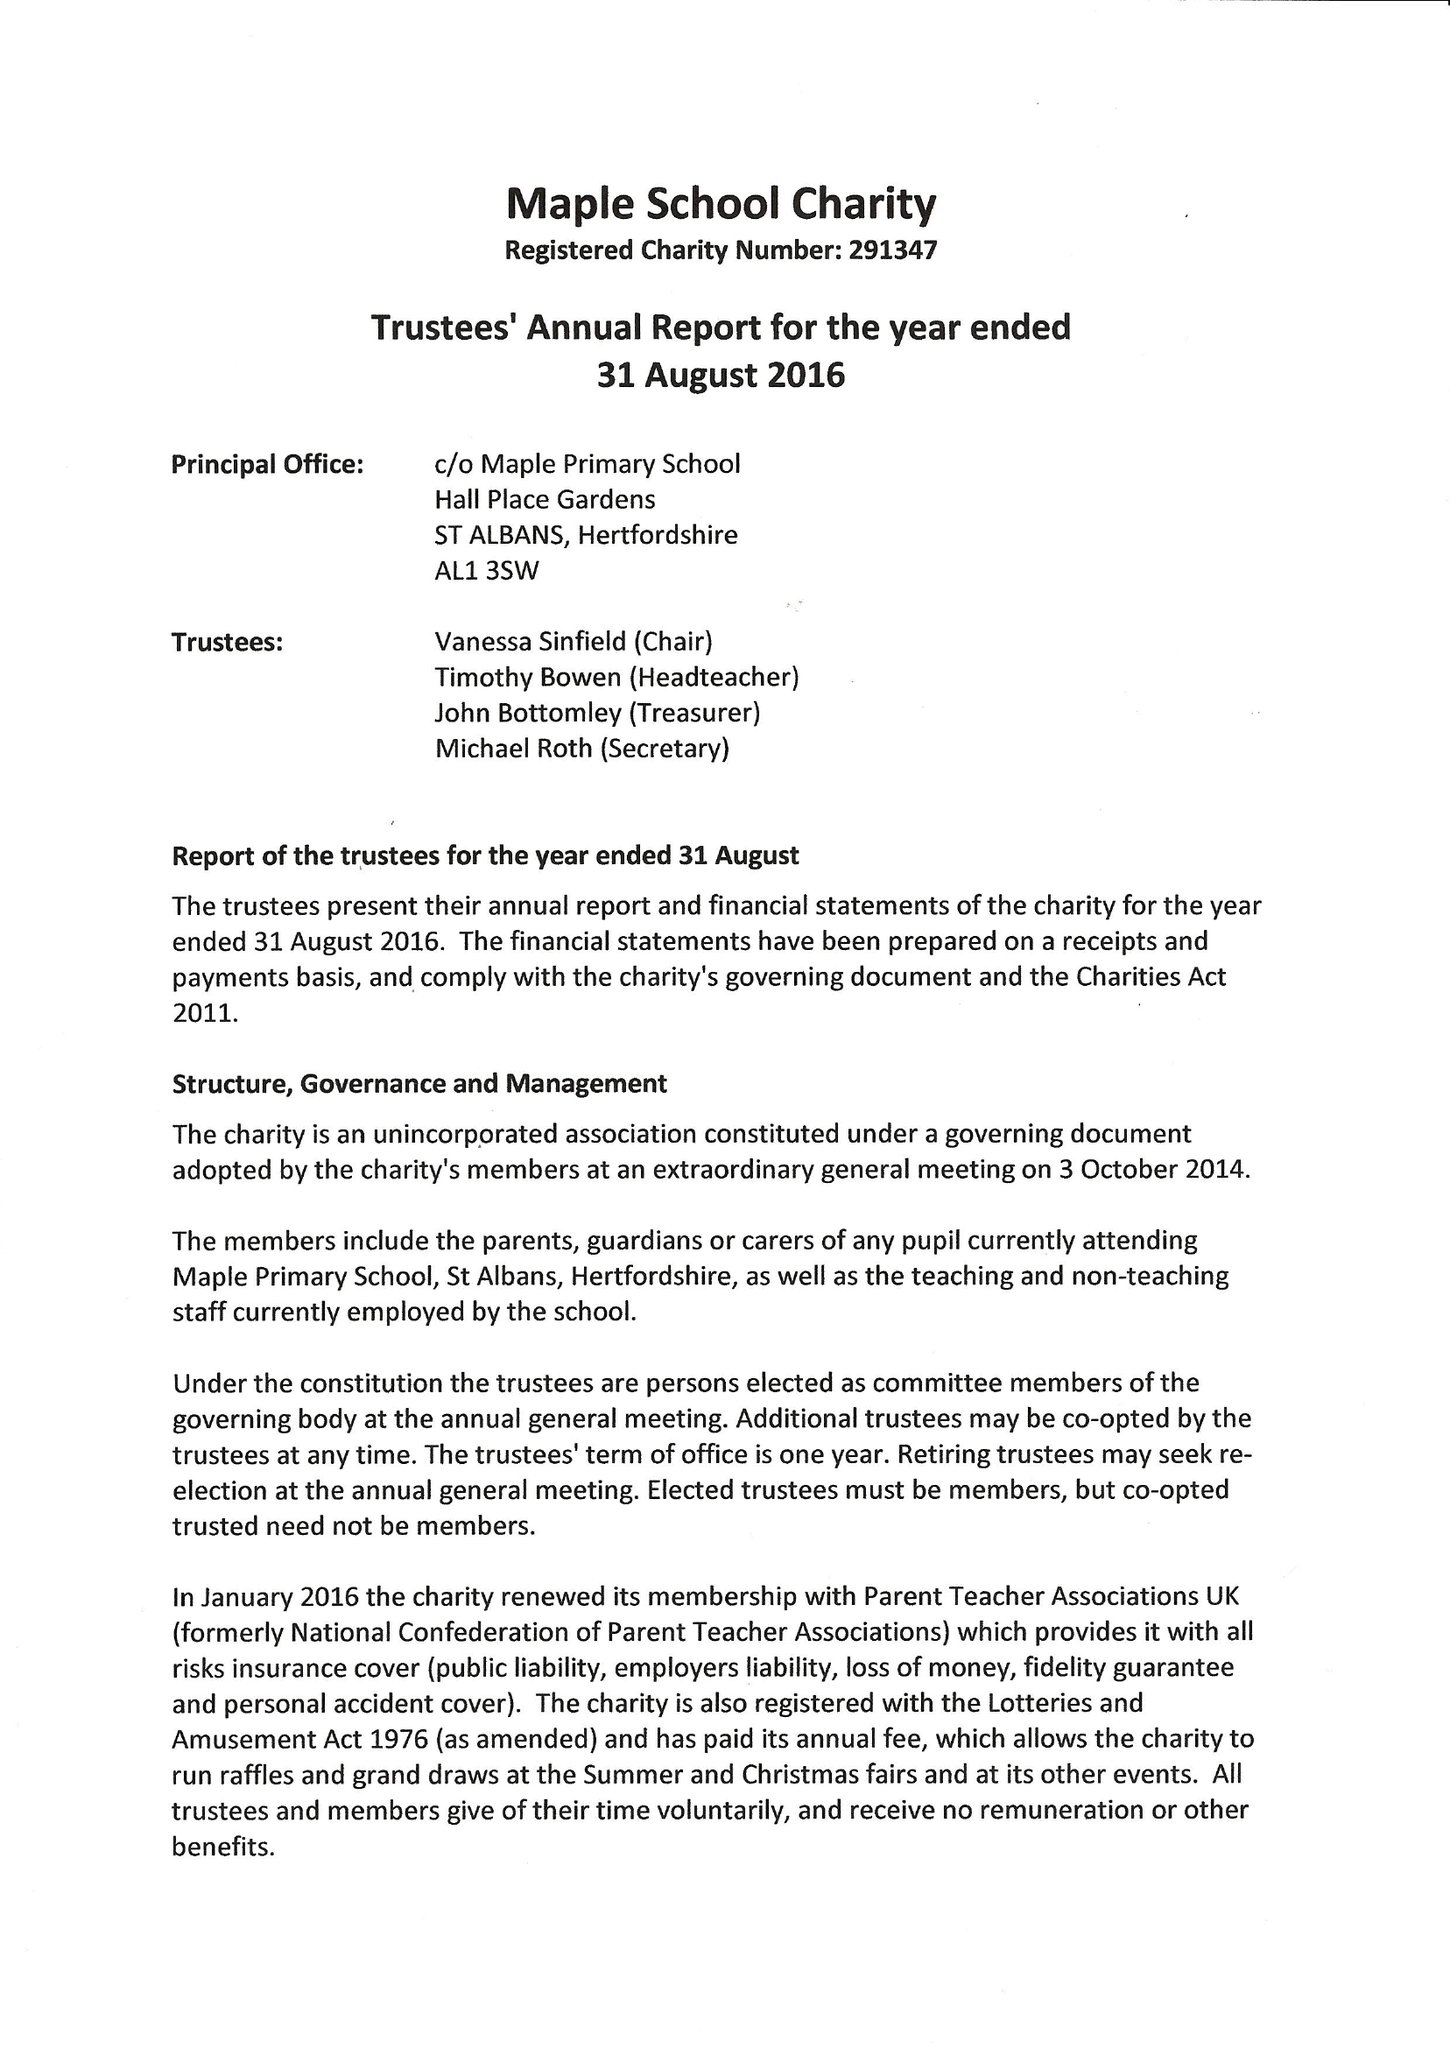What is the value for the income_annually_in_british_pounds?
Answer the question using a single word or phrase. 37798.00 